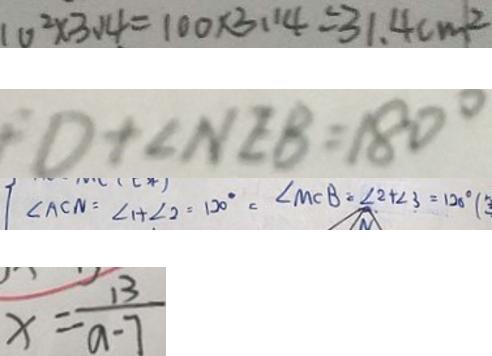<formula> <loc_0><loc_0><loc_500><loc_500>1 0 ^ { 2 } \times 3 . 1 4 = 1 0 0 \times 3 . 1 4 = 3 1 . 4 c m ^ { 2 } 
 D + \angle N E B = 1 8 0 ^ { \circ } 
 \angle A C N = \angle 1 + \angle 2 = 1 2 0 ^ { \circ } = \angle M C B = \angle 2 + \angle 3 = 1 2 0 ^ { \circ } ( 
 x = \frac { 1 3 } { a - 7 }</formula> 